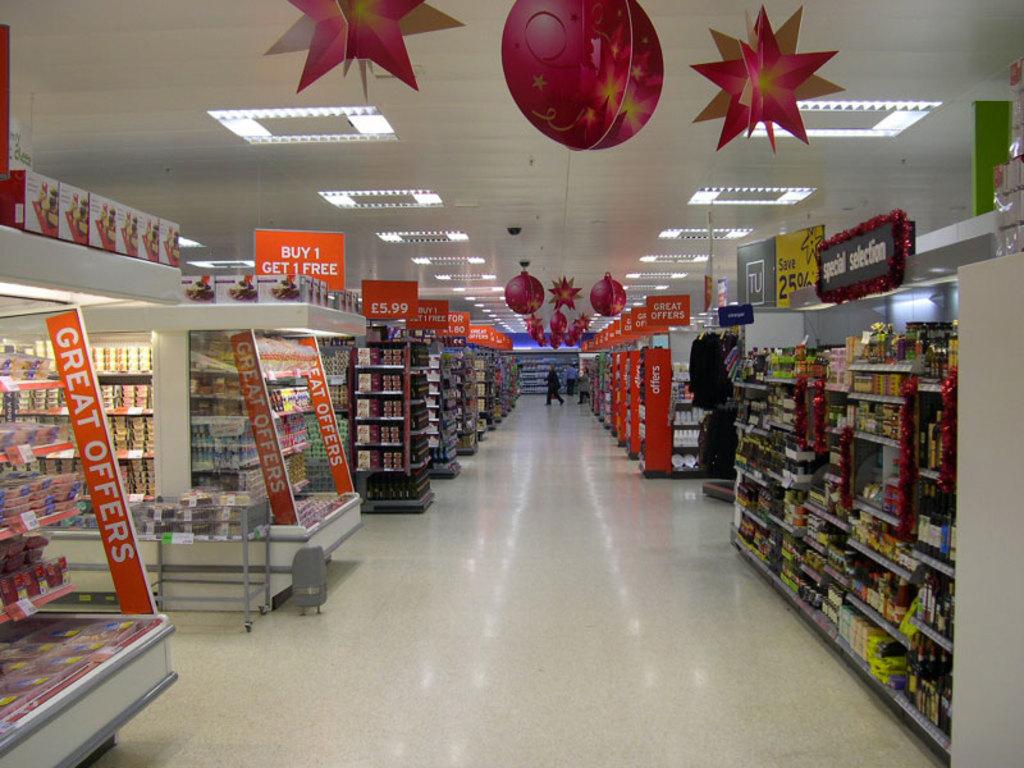What do you get when you buy one?
Your answer should be very brief. 1 free. What kind of offers?
Your answer should be compact. Great. 